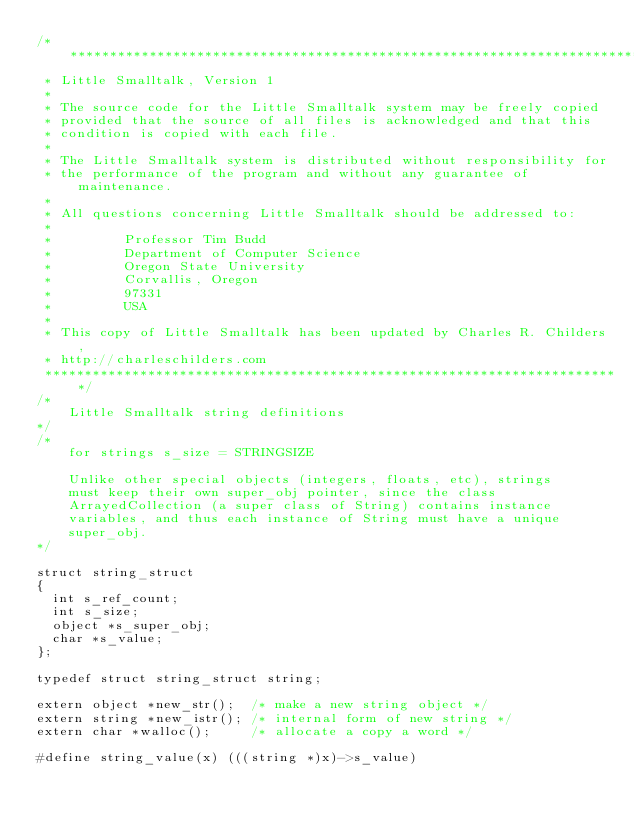<code> <loc_0><loc_0><loc_500><loc_500><_C_>/*************************************************************************
 * Little Smalltalk, Version 1
 *
 * The source code for the Little Smalltalk system may be freely copied
 * provided that the source of all files is acknowledged and that this
 * condition is copied with each file.
 *
 * The Little Smalltalk system is distributed without responsibility for
 * the performance of the program and without any guarantee of maintenance.
 *
 * All questions concerning Little Smalltalk should be addressed to:
 *
 *         Professor Tim Budd
 *         Department of Computer Science
 *         Oregon State University
 *         Corvallis, Oregon
 *         97331
 *         USA
 *
 * This copy of Little Smalltalk has been updated by Charles R. Childers,
 * http://charleschilders.com
 *************************************************************************/
/*
    Little Smalltalk string definitions
*/
/*
    for strings s_size = STRINGSIZE

    Unlike other special objects (integers, floats, etc), strings
    must keep their own super_obj pointer, since the class
    ArrayedCollection (a super class of String) contains instance
    variables, and thus each instance of String must have a unique
    super_obj.
*/

struct string_struct
{
  int s_ref_count;
  int s_size;
  object *s_super_obj;
  char *s_value;
};

typedef struct string_struct string;

extern object *new_str();  /* make a new string object */
extern string *new_istr(); /* internal form of new string */
extern char *walloc();     /* allocate a copy a word */

#define string_value(x) (((string *)x)->s_value)
</code> 